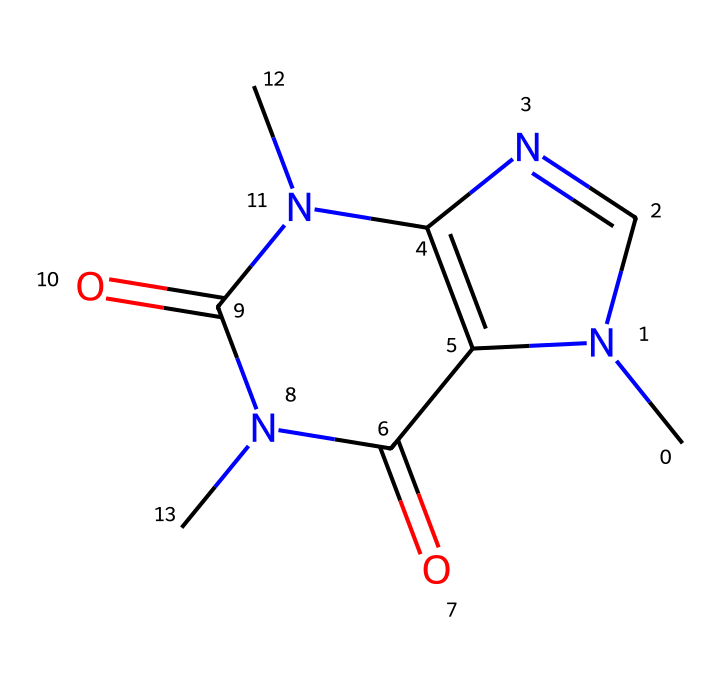What is the molecular formula of caffeine? To determine the molecular formula, we need to identify the number of each type of atom in the SMILES representation. Analyzing the structure, we find 8 carbon (C) atoms, 10 hydrogen (H) atoms, 4 nitrogen (N) atoms, and 2 oxygen (O) atoms. This gives the molecular formula C8H10N4O2.
Answer: C8H10N4O2 How many rings are present in the structure? By examining the structure in the SMILES, it indicates that there are two ring systems due to the presence of the numeric indicators (1 and 2) signifying the start and end of cycles. Thus, the structure contains two rings.
Answer: 2 What type of chemical compound is caffeine? Caffeine is classified as an alkaloid, which are naturally occurring compounds, often basic, that contain nitrogen. The presence of multiple nitrogen atoms in the structure categorizes it within this class of chemicals.
Answer: alkaloid What is the primary functional group in caffeine? In analyzing the structure, the presence of the carbonyl groups (C=O) is noted. These are key functional groups in caffeine, as they play a significant role in its chemical reactivity and properties.
Answer: carbonyl How many nitrogen atoms are in caffeine? Counting the nitrogen (N) atoms in the structure from the SMILES, we observe four distinct nitrogen atoms. This is confirmed by the structure itself, as all nitrogen locations are clear.
Answer: 4 